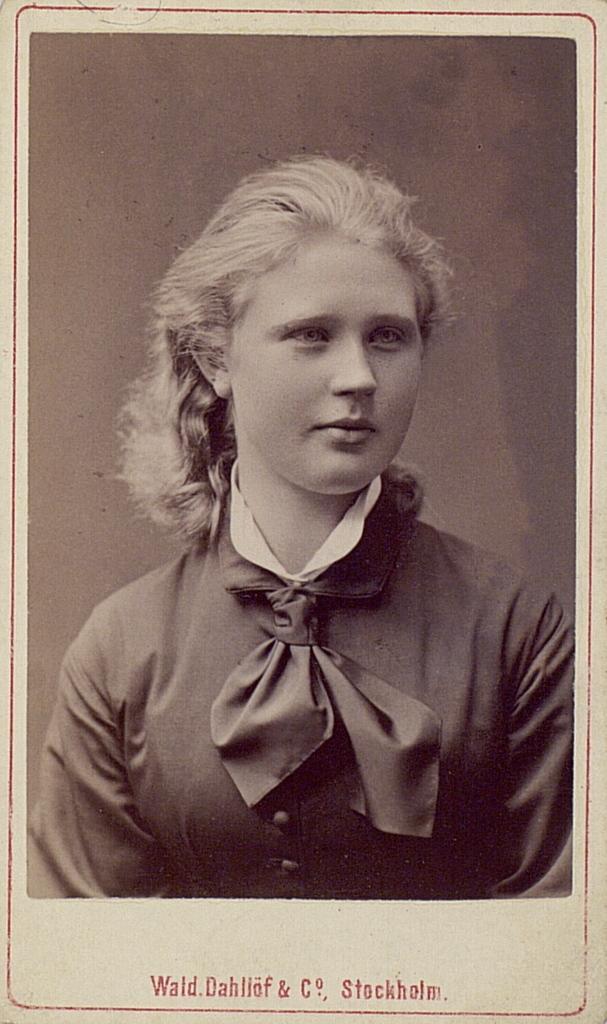Can you describe this image briefly? In this image we can see a photograph of a girl. At the bottom of the image text is written. 